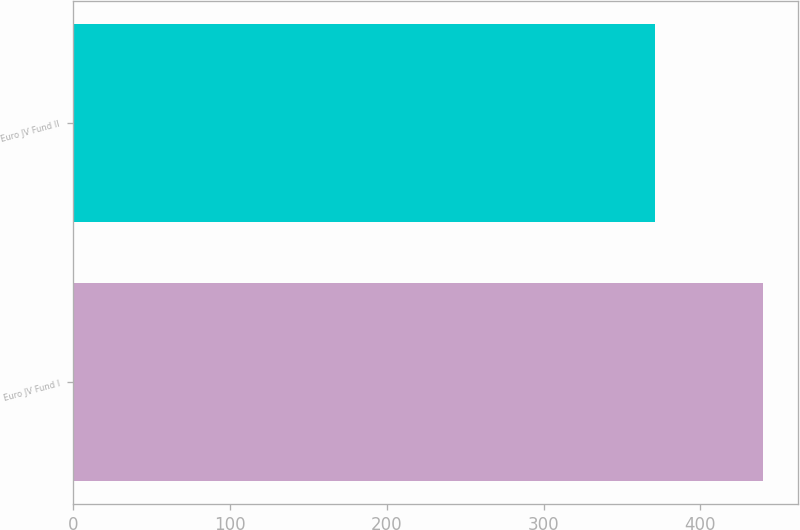Convert chart to OTSL. <chart><loc_0><loc_0><loc_500><loc_500><bar_chart><fcel>Euro JV Fund I<fcel>Euro JV Fund II<nl><fcel>440<fcel>371<nl></chart> 